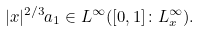<formula> <loc_0><loc_0><loc_500><loc_500>| x | ^ { 2 / 3 } a _ { 1 } \in L ^ { \infty } ( [ 0 , 1 ] \colon L _ { x } ^ { \infty } ) .</formula> 